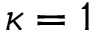Convert formula to latex. <formula><loc_0><loc_0><loc_500><loc_500>\kappa = 1</formula> 